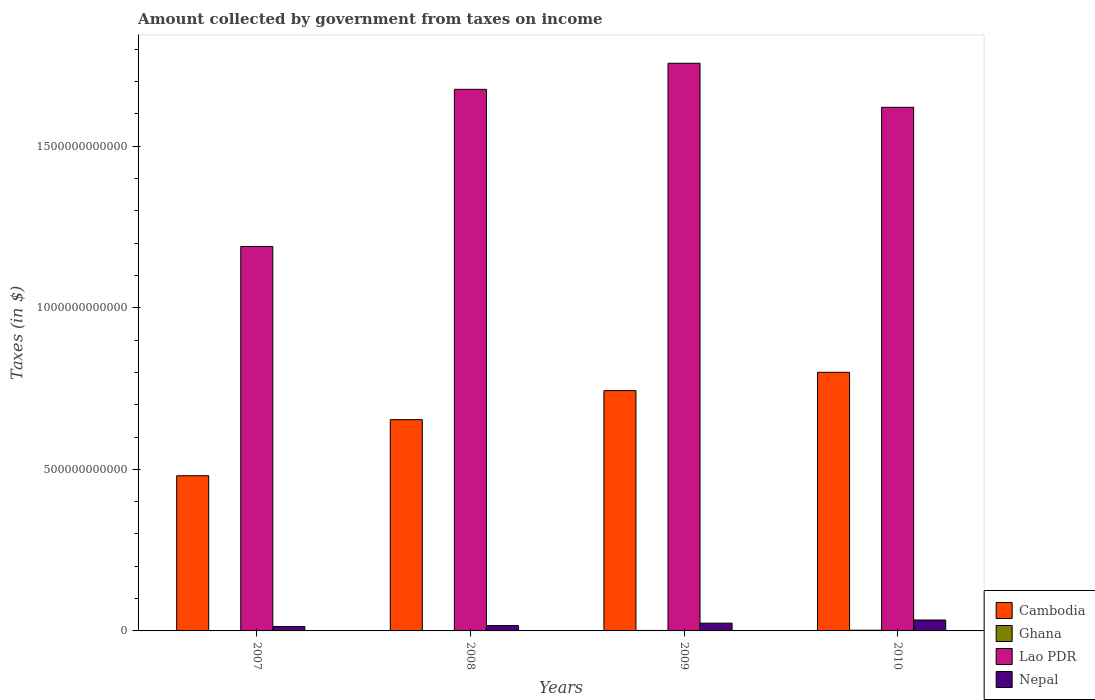How many groups of bars are there?
Provide a short and direct response. 4. Are the number of bars per tick equal to the number of legend labels?
Offer a very short reply. Yes. Are the number of bars on each tick of the X-axis equal?
Offer a terse response. Yes. How many bars are there on the 4th tick from the right?
Your answer should be compact. 4. What is the amount collected by government from taxes on income in Lao PDR in 2009?
Make the answer very short. 1.76e+12. Across all years, what is the maximum amount collected by government from taxes on income in Cambodia?
Offer a terse response. 8.00e+11. Across all years, what is the minimum amount collected by government from taxes on income in Nepal?
Make the answer very short. 1.37e+1. In which year was the amount collected by government from taxes on income in Ghana maximum?
Provide a short and direct response. 2010. In which year was the amount collected by government from taxes on income in Lao PDR minimum?
Offer a very short reply. 2007. What is the total amount collected by government from taxes on income in Cambodia in the graph?
Provide a succinct answer. 2.68e+12. What is the difference between the amount collected by government from taxes on income in Nepal in 2009 and that in 2010?
Make the answer very short. -9.77e+09. What is the difference between the amount collected by government from taxes on income in Lao PDR in 2010 and the amount collected by government from taxes on income in Nepal in 2009?
Make the answer very short. 1.60e+12. What is the average amount collected by government from taxes on income in Nepal per year?
Provide a succinct answer. 2.21e+1. In the year 2010, what is the difference between the amount collected by government from taxes on income in Nepal and amount collected by government from taxes on income in Cambodia?
Offer a terse response. -7.67e+11. In how many years, is the amount collected by government from taxes on income in Ghana greater than 1500000000000 $?
Your response must be concise. 0. What is the ratio of the amount collected by government from taxes on income in Cambodia in 2007 to that in 2010?
Provide a short and direct response. 0.6. What is the difference between the highest and the second highest amount collected by government from taxes on income in Lao PDR?
Provide a succinct answer. 8.07e+1. What is the difference between the highest and the lowest amount collected by government from taxes on income in Ghana?
Provide a succinct answer. 1.34e+09. In how many years, is the amount collected by government from taxes on income in Lao PDR greater than the average amount collected by government from taxes on income in Lao PDR taken over all years?
Make the answer very short. 3. Is the sum of the amount collected by government from taxes on income in Ghana in 2007 and 2009 greater than the maximum amount collected by government from taxes on income in Cambodia across all years?
Make the answer very short. No. Is it the case that in every year, the sum of the amount collected by government from taxes on income in Nepal and amount collected by government from taxes on income in Cambodia is greater than the sum of amount collected by government from taxes on income in Lao PDR and amount collected by government from taxes on income in Ghana?
Provide a succinct answer. No. What does the 4th bar from the right in 2010 represents?
Make the answer very short. Cambodia. Is it the case that in every year, the sum of the amount collected by government from taxes on income in Lao PDR and amount collected by government from taxes on income in Nepal is greater than the amount collected by government from taxes on income in Ghana?
Ensure brevity in your answer.  Yes. How many bars are there?
Make the answer very short. 16. Are all the bars in the graph horizontal?
Give a very brief answer. No. What is the difference between two consecutive major ticks on the Y-axis?
Give a very brief answer. 5.00e+11. Are the values on the major ticks of Y-axis written in scientific E-notation?
Offer a very short reply. No. Does the graph contain grids?
Your answer should be compact. No. Where does the legend appear in the graph?
Offer a very short reply. Bottom right. How are the legend labels stacked?
Your answer should be compact. Vertical. What is the title of the graph?
Your response must be concise. Amount collected by government from taxes on income. What is the label or title of the Y-axis?
Keep it short and to the point. Taxes (in $). What is the Taxes (in $) of Cambodia in 2007?
Your answer should be compact. 4.80e+11. What is the Taxes (in $) of Ghana in 2007?
Keep it short and to the point. 8.57e+08. What is the Taxes (in $) of Lao PDR in 2007?
Keep it short and to the point. 1.19e+12. What is the Taxes (in $) of Nepal in 2007?
Ensure brevity in your answer.  1.37e+1. What is the Taxes (in $) of Cambodia in 2008?
Your response must be concise. 6.54e+11. What is the Taxes (in $) of Ghana in 2008?
Make the answer very short. 1.13e+09. What is the Taxes (in $) in Lao PDR in 2008?
Offer a terse response. 1.68e+12. What is the Taxes (in $) of Nepal in 2008?
Your response must be concise. 1.66e+1. What is the Taxes (in $) of Cambodia in 2009?
Provide a short and direct response. 7.44e+11. What is the Taxes (in $) of Ghana in 2009?
Provide a short and direct response. 1.54e+09. What is the Taxes (in $) of Lao PDR in 2009?
Give a very brief answer. 1.76e+12. What is the Taxes (in $) in Nepal in 2009?
Offer a very short reply. 2.41e+1. What is the Taxes (in $) of Cambodia in 2010?
Ensure brevity in your answer.  8.00e+11. What is the Taxes (in $) of Ghana in 2010?
Your answer should be compact. 2.19e+09. What is the Taxes (in $) of Lao PDR in 2010?
Your answer should be very brief. 1.62e+12. What is the Taxes (in $) in Nepal in 2010?
Ensure brevity in your answer.  3.38e+1. Across all years, what is the maximum Taxes (in $) in Cambodia?
Make the answer very short. 8.00e+11. Across all years, what is the maximum Taxes (in $) of Ghana?
Offer a very short reply. 2.19e+09. Across all years, what is the maximum Taxes (in $) of Lao PDR?
Offer a very short reply. 1.76e+12. Across all years, what is the maximum Taxes (in $) in Nepal?
Provide a short and direct response. 3.38e+1. Across all years, what is the minimum Taxes (in $) of Cambodia?
Keep it short and to the point. 4.80e+11. Across all years, what is the minimum Taxes (in $) of Ghana?
Keep it short and to the point. 8.57e+08. Across all years, what is the minimum Taxes (in $) of Lao PDR?
Your response must be concise. 1.19e+12. Across all years, what is the minimum Taxes (in $) of Nepal?
Ensure brevity in your answer.  1.37e+1. What is the total Taxes (in $) in Cambodia in the graph?
Your answer should be very brief. 2.68e+12. What is the total Taxes (in $) in Ghana in the graph?
Your answer should be compact. 5.73e+09. What is the total Taxes (in $) of Lao PDR in the graph?
Provide a succinct answer. 6.24e+12. What is the total Taxes (in $) in Nepal in the graph?
Your answer should be compact. 8.82e+1. What is the difference between the Taxes (in $) of Cambodia in 2007 and that in 2008?
Give a very brief answer. -1.74e+11. What is the difference between the Taxes (in $) of Ghana in 2007 and that in 2008?
Offer a terse response. -2.77e+08. What is the difference between the Taxes (in $) in Lao PDR in 2007 and that in 2008?
Your answer should be very brief. -4.86e+11. What is the difference between the Taxes (in $) of Nepal in 2007 and that in 2008?
Your answer should be very brief. -2.90e+09. What is the difference between the Taxes (in $) in Cambodia in 2007 and that in 2009?
Your answer should be compact. -2.63e+11. What is the difference between the Taxes (in $) of Ghana in 2007 and that in 2009?
Keep it short and to the point. -6.81e+08. What is the difference between the Taxes (in $) in Lao PDR in 2007 and that in 2009?
Give a very brief answer. -5.67e+11. What is the difference between the Taxes (in $) of Nepal in 2007 and that in 2009?
Make the answer very short. -1.03e+1. What is the difference between the Taxes (in $) of Cambodia in 2007 and that in 2010?
Give a very brief answer. -3.20e+11. What is the difference between the Taxes (in $) of Ghana in 2007 and that in 2010?
Your answer should be very brief. -1.34e+09. What is the difference between the Taxes (in $) of Lao PDR in 2007 and that in 2010?
Your answer should be compact. -4.31e+11. What is the difference between the Taxes (in $) in Nepal in 2007 and that in 2010?
Your answer should be compact. -2.01e+1. What is the difference between the Taxes (in $) in Cambodia in 2008 and that in 2009?
Offer a very short reply. -8.98e+1. What is the difference between the Taxes (in $) in Ghana in 2008 and that in 2009?
Offer a very short reply. -4.04e+08. What is the difference between the Taxes (in $) in Lao PDR in 2008 and that in 2009?
Your answer should be very brief. -8.07e+1. What is the difference between the Taxes (in $) of Nepal in 2008 and that in 2009?
Give a very brief answer. -7.42e+09. What is the difference between the Taxes (in $) of Cambodia in 2008 and that in 2010?
Make the answer very short. -1.47e+11. What is the difference between the Taxes (in $) in Ghana in 2008 and that in 2010?
Your answer should be very brief. -1.06e+09. What is the difference between the Taxes (in $) in Lao PDR in 2008 and that in 2010?
Provide a succinct answer. 5.56e+1. What is the difference between the Taxes (in $) in Nepal in 2008 and that in 2010?
Provide a short and direct response. -1.72e+1. What is the difference between the Taxes (in $) in Cambodia in 2009 and that in 2010?
Your answer should be very brief. -5.67e+1. What is the difference between the Taxes (in $) in Ghana in 2009 and that in 2010?
Give a very brief answer. -6.57e+08. What is the difference between the Taxes (in $) of Lao PDR in 2009 and that in 2010?
Offer a very short reply. 1.36e+11. What is the difference between the Taxes (in $) of Nepal in 2009 and that in 2010?
Your response must be concise. -9.77e+09. What is the difference between the Taxes (in $) of Cambodia in 2007 and the Taxes (in $) of Ghana in 2008?
Your answer should be very brief. 4.79e+11. What is the difference between the Taxes (in $) of Cambodia in 2007 and the Taxes (in $) of Lao PDR in 2008?
Your answer should be compact. -1.20e+12. What is the difference between the Taxes (in $) in Cambodia in 2007 and the Taxes (in $) in Nepal in 2008?
Offer a very short reply. 4.64e+11. What is the difference between the Taxes (in $) of Ghana in 2007 and the Taxes (in $) of Lao PDR in 2008?
Provide a short and direct response. -1.68e+12. What is the difference between the Taxes (in $) in Ghana in 2007 and the Taxes (in $) in Nepal in 2008?
Ensure brevity in your answer.  -1.58e+1. What is the difference between the Taxes (in $) in Lao PDR in 2007 and the Taxes (in $) in Nepal in 2008?
Your answer should be compact. 1.17e+12. What is the difference between the Taxes (in $) in Cambodia in 2007 and the Taxes (in $) in Ghana in 2009?
Your answer should be very brief. 4.79e+11. What is the difference between the Taxes (in $) in Cambodia in 2007 and the Taxes (in $) in Lao PDR in 2009?
Keep it short and to the point. -1.28e+12. What is the difference between the Taxes (in $) of Cambodia in 2007 and the Taxes (in $) of Nepal in 2009?
Offer a terse response. 4.56e+11. What is the difference between the Taxes (in $) in Ghana in 2007 and the Taxes (in $) in Lao PDR in 2009?
Provide a succinct answer. -1.76e+12. What is the difference between the Taxes (in $) in Ghana in 2007 and the Taxes (in $) in Nepal in 2009?
Make the answer very short. -2.32e+1. What is the difference between the Taxes (in $) in Lao PDR in 2007 and the Taxes (in $) in Nepal in 2009?
Offer a very short reply. 1.17e+12. What is the difference between the Taxes (in $) in Cambodia in 2007 and the Taxes (in $) in Ghana in 2010?
Ensure brevity in your answer.  4.78e+11. What is the difference between the Taxes (in $) of Cambodia in 2007 and the Taxes (in $) of Lao PDR in 2010?
Make the answer very short. -1.14e+12. What is the difference between the Taxes (in $) in Cambodia in 2007 and the Taxes (in $) in Nepal in 2010?
Your answer should be very brief. 4.46e+11. What is the difference between the Taxes (in $) in Ghana in 2007 and the Taxes (in $) in Lao PDR in 2010?
Give a very brief answer. -1.62e+12. What is the difference between the Taxes (in $) of Ghana in 2007 and the Taxes (in $) of Nepal in 2010?
Offer a very short reply. -3.30e+1. What is the difference between the Taxes (in $) of Lao PDR in 2007 and the Taxes (in $) of Nepal in 2010?
Offer a very short reply. 1.16e+12. What is the difference between the Taxes (in $) in Cambodia in 2008 and the Taxes (in $) in Ghana in 2009?
Your response must be concise. 6.52e+11. What is the difference between the Taxes (in $) in Cambodia in 2008 and the Taxes (in $) in Lao PDR in 2009?
Offer a terse response. -1.10e+12. What is the difference between the Taxes (in $) of Cambodia in 2008 and the Taxes (in $) of Nepal in 2009?
Ensure brevity in your answer.  6.30e+11. What is the difference between the Taxes (in $) in Ghana in 2008 and the Taxes (in $) in Lao PDR in 2009?
Provide a succinct answer. -1.76e+12. What is the difference between the Taxes (in $) of Ghana in 2008 and the Taxes (in $) of Nepal in 2009?
Make the answer very short. -2.29e+1. What is the difference between the Taxes (in $) in Lao PDR in 2008 and the Taxes (in $) in Nepal in 2009?
Give a very brief answer. 1.65e+12. What is the difference between the Taxes (in $) of Cambodia in 2008 and the Taxes (in $) of Ghana in 2010?
Provide a short and direct response. 6.52e+11. What is the difference between the Taxes (in $) of Cambodia in 2008 and the Taxes (in $) of Lao PDR in 2010?
Your answer should be very brief. -9.67e+11. What is the difference between the Taxes (in $) of Cambodia in 2008 and the Taxes (in $) of Nepal in 2010?
Offer a terse response. 6.20e+11. What is the difference between the Taxes (in $) of Ghana in 2008 and the Taxes (in $) of Lao PDR in 2010?
Offer a terse response. -1.62e+12. What is the difference between the Taxes (in $) of Ghana in 2008 and the Taxes (in $) of Nepal in 2010?
Offer a very short reply. -3.27e+1. What is the difference between the Taxes (in $) in Lao PDR in 2008 and the Taxes (in $) in Nepal in 2010?
Offer a very short reply. 1.64e+12. What is the difference between the Taxes (in $) of Cambodia in 2009 and the Taxes (in $) of Ghana in 2010?
Your response must be concise. 7.41e+11. What is the difference between the Taxes (in $) in Cambodia in 2009 and the Taxes (in $) in Lao PDR in 2010?
Provide a succinct answer. -8.77e+11. What is the difference between the Taxes (in $) in Cambodia in 2009 and the Taxes (in $) in Nepal in 2010?
Provide a succinct answer. 7.10e+11. What is the difference between the Taxes (in $) in Ghana in 2009 and the Taxes (in $) in Lao PDR in 2010?
Provide a short and direct response. -1.62e+12. What is the difference between the Taxes (in $) of Ghana in 2009 and the Taxes (in $) of Nepal in 2010?
Provide a short and direct response. -3.23e+1. What is the difference between the Taxes (in $) of Lao PDR in 2009 and the Taxes (in $) of Nepal in 2010?
Offer a terse response. 1.72e+12. What is the average Taxes (in $) in Cambodia per year?
Give a very brief answer. 6.70e+11. What is the average Taxes (in $) in Ghana per year?
Your response must be concise. 1.43e+09. What is the average Taxes (in $) of Lao PDR per year?
Give a very brief answer. 1.56e+12. What is the average Taxes (in $) in Nepal per year?
Provide a short and direct response. 2.21e+1. In the year 2007, what is the difference between the Taxes (in $) of Cambodia and Taxes (in $) of Ghana?
Your response must be concise. 4.79e+11. In the year 2007, what is the difference between the Taxes (in $) in Cambodia and Taxes (in $) in Lao PDR?
Keep it short and to the point. -7.09e+11. In the year 2007, what is the difference between the Taxes (in $) of Cambodia and Taxes (in $) of Nepal?
Ensure brevity in your answer.  4.67e+11. In the year 2007, what is the difference between the Taxes (in $) in Ghana and Taxes (in $) in Lao PDR?
Your answer should be compact. -1.19e+12. In the year 2007, what is the difference between the Taxes (in $) of Ghana and Taxes (in $) of Nepal?
Give a very brief answer. -1.29e+1. In the year 2007, what is the difference between the Taxes (in $) of Lao PDR and Taxes (in $) of Nepal?
Make the answer very short. 1.18e+12. In the year 2008, what is the difference between the Taxes (in $) in Cambodia and Taxes (in $) in Ghana?
Your answer should be very brief. 6.53e+11. In the year 2008, what is the difference between the Taxes (in $) in Cambodia and Taxes (in $) in Lao PDR?
Ensure brevity in your answer.  -1.02e+12. In the year 2008, what is the difference between the Taxes (in $) in Cambodia and Taxes (in $) in Nepal?
Offer a very short reply. 6.37e+11. In the year 2008, what is the difference between the Taxes (in $) in Ghana and Taxes (in $) in Lao PDR?
Offer a terse response. -1.68e+12. In the year 2008, what is the difference between the Taxes (in $) of Ghana and Taxes (in $) of Nepal?
Give a very brief answer. -1.55e+1. In the year 2008, what is the difference between the Taxes (in $) in Lao PDR and Taxes (in $) in Nepal?
Ensure brevity in your answer.  1.66e+12. In the year 2009, what is the difference between the Taxes (in $) of Cambodia and Taxes (in $) of Ghana?
Provide a succinct answer. 7.42e+11. In the year 2009, what is the difference between the Taxes (in $) of Cambodia and Taxes (in $) of Lao PDR?
Make the answer very short. -1.01e+12. In the year 2009, what is the difference between the Taxes (in $) of Cambodia and Taxes (in $) of Nepal?
Offer a terse response. 7.20e+11. In the year 2009, what is the difference between the Taxes (in $) of Ghana and Taxes (in $) of Lao PDR?
Your response must be concise. -1.76e+12. In the year 2009, what is the difference between the Taxes (in $) of Ghana and Taxes (in $) of Nepal?
Offer a very short reply. -2.25e+1. In the year 2009, what is the difference between the Taxes (in $) of Lao PDR and Taxes (in $) of Nepal?
Make the answer very short. 1.73e+12. In the year 2010, what is the difference between the Taxes (in $) in Cambodia and Taxes (in $) in Ghana?
Your answer should be very brief. 7.98e+11. In the year 2010, what is the difference between the Taxes (in $) in Cambodia and Taxes (in $) in Lao PDR?
Provide a short and direct response. -8.20e+11. In the year 2010, what is the difference between the Taxes (in $) of Cambodia and Taxes (in $) of Nepal?
Provide a short and direct response. 7.67e+11. In the year 2010, what is the difference between the Taxes (in $) in Ghana and Taxes (in $) in Lao PDR?
Keep it short and to the point. -1.62e+12. In the year 2010, what is the difference between the Taxes (in $) of Ghana and Taxes (in $) of Nepal?
Offer a very short reply. -3.16e+1. In the year 2010, what is the difference between the Taxes (in $) of Lao PDR and Taxes (in $) of Nepal?
Make the answer very short. 1.59e+12. What is the ratio of the Taxes (in $) of Cambodia in 2007 to that in 2008?
Provide a succinct answer. 0.73. What is the ratio of the Taxes (in $) of Ghana in 2007 to that in 2008?
Offer a very short reply. 0.76. What is the ratio of the Taxes (in $) in Lao PDR in 2007 to that in 2008?
Keep it short and to the point. 0.71. What is the ratio of the Taxes (in $) in Nepal in 2007 to that in 2008?
Offer a very short reply. 0.83. What is the ratio of the Taxes (in $) of Cambodia in 2007 to that in 2009?
Your response must be concise. 0.65. What is the ratio of the Taxes (in $) in Ghana in 2007 to that in 2009?
Offer a very short reply. 0.56. What is the ratio of the Taxes (in $) of Lao PDR in 2007 to that in 2009?
Offer a very short reply. 0.68. What is the ratio of the Taxes (in $) of Nepal in 2007 to that in 2009?
Provide a short and direct response. 0.57. What is the ratio of the Taxes (in $) of Cambodia in 2007 to that in 2010?
Give a very brief answer. 0.6. What is the ratio of the Taxes (in $) of Ghana in 2007 to that in 2010?
Offer a terse response. 0.39. What is the ratio of the Taxes (in $) in Lao PDR in 2007 to that in 2010?
Your answer should be very brief. 0.73. What is the ratio of the Taxes (in $) in Nepal in 2007 to that in 2010?
Your response must be concise. 0.41. What is the ratio of the Taxes (in $) of Cambodia in 2008 to that in 2009?
Provide a short and direct response. 0.88. What is the ratio of the Taxes (in $) in Ghana in 2008 to that in 2009?
Your answer should be compact. 0.74. What is the ratio of the Taxes (in $) in Lao PDR in 2008 to that in 2009?
Provide a short and direct response. 0.95. What is the ratio of the Taxes (in $) in Nepal in 2008 to that in 2009?
Provide a succinct answer. 0.69. What is the ratio of the Taxes (in $) in Cambodia in 2008 to that in 2010?
Ensure brevity in your answer.  0.82. What is the ratio of the Taxes (in $) of Ghana in 2008 to that in 2010?
Provide a short and direct response. 0.52. What is the ratio of the Taxes (in $) of Lao PDR in 2008 to that in 2010?
Your answer should be compact. 1.03. What is the ratio of the Taxes (in $) in Nepal in 2008 to that in 2010?
Provide a short and direct response. 0.49. What is the ratio of the Taxes (in $) in Cambodia in 2009 to that in 2010?
Ensure brevity in your answer.  0.93. What is the ratio of the Taxes (in $) of Ghana in 2009 to that in 2010?
Your answer should be compact. 0.7. What is the ratio of the Taxes (in $) of Lao PDR in 2009 to that in 2010?
Provide a short and direct response. 1.08. What is the ratio of the Taxes (in $) in Nepal in 2009 to that in 2010?
Keep it short and to the point. 0.71. What is the difference between the highest and the second highest Taxes (in $) in Cambodia?
Provide a short and direct response. 5.67e+1. What is the difference between the highest and the second highest Taxes (in $) of Ghana?
Your answer should be compact. 6.57e+08. What is the difference between the highest and the second highest Taxes (in $) of Lao PDR?
Offer a very short reply. 8.07e+1. What is the difference between the highest and the second highest Taxes (in $) of Nepal?
Give a very brief answer. 9.77e+09. What is the difference between the highest and the lowest Taxes (in $) of Cambodia?
Provide a short and direct response. 3.20e+11. What is the difference between the highest and the lowest Taxes (in $) in Ghana?
Ensure brevity in your answer.  1.34e+09. What is the difference between the highest and the lowest Taxes (in $) of Lao PDR?
Your response must be concise. 5.67e+11. What is the difference between the highest and the lowest Taxes (in $) in Nepal?
Keep it short and to the point. 2.01e+1. 